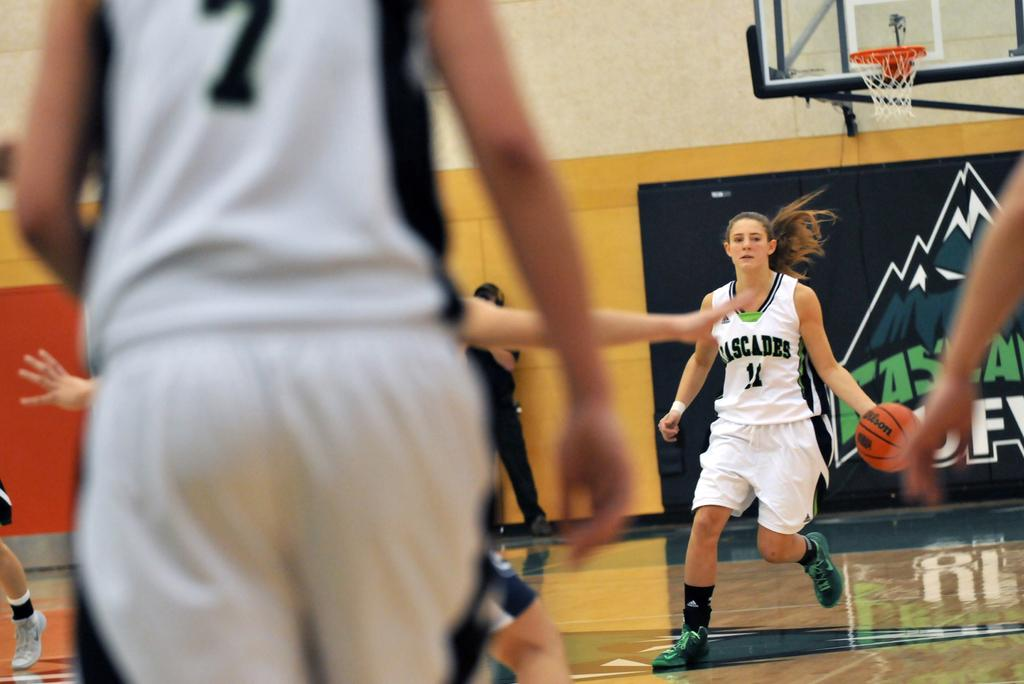<image>
Describe the image concisely. A basketball player has a jersey with the word Cascades on it. 